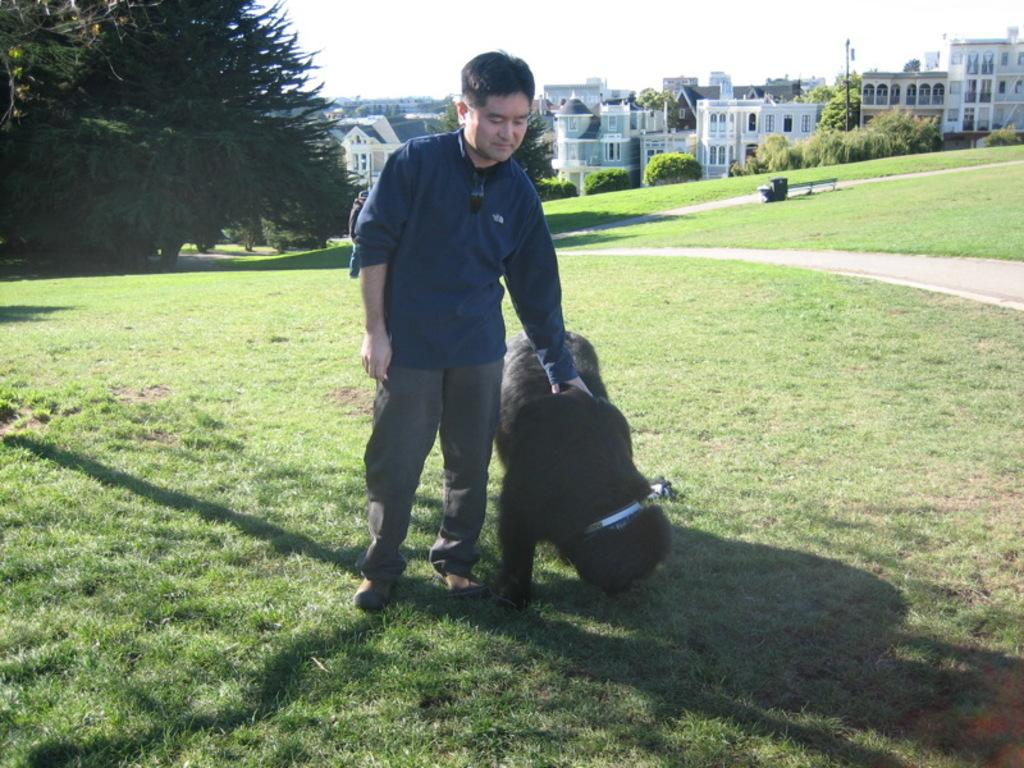What is happening in the image? There is a person in the image holding an animal. What is the setting of the image? Both the person and the animal are standing on grassy land, with trees and buildings visible in the background. What is the weather like in the image? The background is sunny, suggesting a clear day. What type of crib is visible in the image? There is no crib present in the image. How does the person use a mitten to interact with the animal in the image? There is no mitten present in the image, and the person is not using one to interact with the animal. 